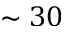Convert formula to latex. <formula><loc_0><loc_0><loc_500><loc_500>\sim 3 0</formula> 